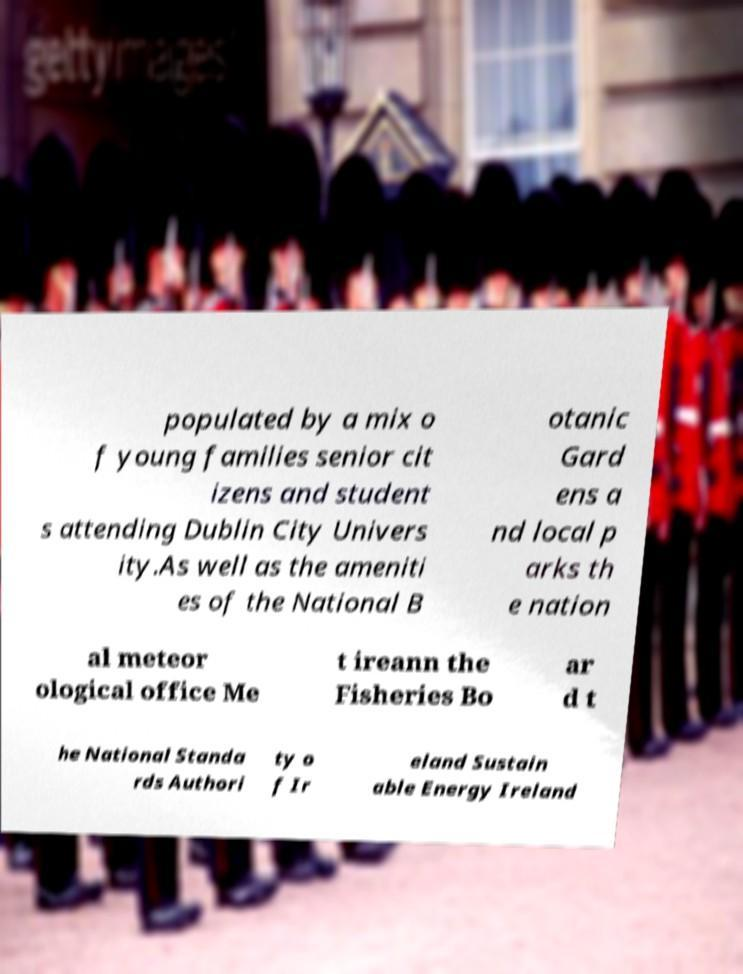There's text embedded in this image that I need extracted. Can you transcribe it verbatim? populated by a mix o f young families senior cit izens and student s attending Dublin City Univers ity.As well as the ameniti es of the National B otanic Gard ens a nd local p arks th e nation al meteor ological office Me t ireann the Fisheries Bo ar d t he National Standa rds Authori ty o f Ir eland Sustain able Energy Ireland 